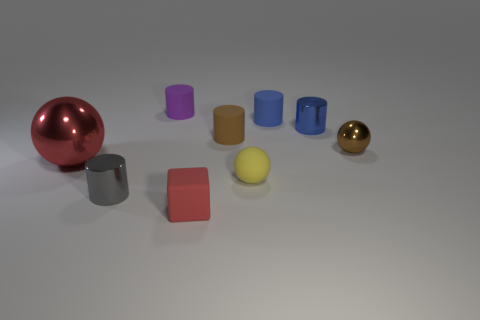Subtract all tiny spheres. How many spheres are left? 1 Subtract 1 spheres. How many spheres are left? 2 Subtract all red balls. How many balls are left? 2 Add 1 tiny matte cubes. How many objects exist? 10 Add 3 blue shiny cylinders. How many blue shiny cylinders are left? 4 Add 6 small matte cubes. How many small matte cubes exist? 7 Subtract 0 blue blocks. How many objects are left? 9 Subtract all balls. How many objects are left? 6 Subtract all cyan cylinders. Subtract all brown balls. How many cylinders are left? 5 Subtract all green cubes. How many blue cylinders are left? 2 